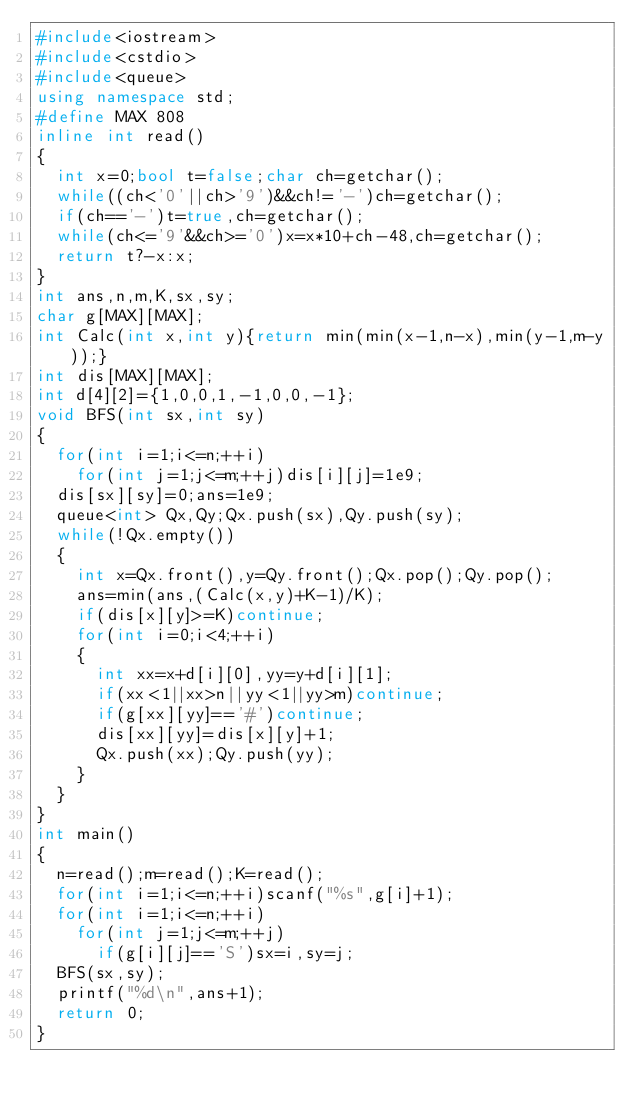<code> <loc_0><loc_0><loc_500><loc_500><_C++_>#include<iostream>
#include<cstdio>
#include<queue>
using namespace std;
#define MAX 808
inline int read()
{
	int x=0;bool t=false;char ch=getchar();
	while((ch<'0'||ch>'9')&&ch!='-')ch=getchar();
	if(ch=='-')t=true,ch=getchar();
	while(ch<='9'&&ch>='0')x=x*10+ch-48,ch=getchar();
	return t?-x:x;
}
int ans,n,m,K,sx,sy;
char g[MAX][MAX];
int Calc(int x,int y){return min(min(x-1,n-x),min(y-1,m-y));}
int dis[MAX][MAX];
int d[4][2]={1,0,0,1,-1,0,0,-1};
void BFS(int sx,int sy)
{
	for(int i=1;i<=n;++i)
		for(int j=1;j<=m;++j)dis[i][j]=1e9;
	dis[sx][sy]=0;ans=1e9;
	queue<int> Qx,Qy;Qx.push(sx),Qy.push(sy);
	while(!Qx.empty())
	{
		int x=Qx.front(),y=Qy.front();Qx.pop();Qy.pop();
		ans=min(ans,(Calc(x,y)+K-1)/K);
		if(dis[x][y]>=K)continue;
		for(int i=0;i<4;++i)
		{
			int xx=x+d[i][0],yy=y+d[i][1];
			if(xx<1||xx>n||yy<1||yy>m)continue;
			if(g[xx][yy]=='#')continue;
			dis[xx][yy]=dis[x][y]+1;
			Qx.push(xx);Qy.push(yy);
		}
	}
}
int main()
{
	n=read();m=read();K=read();
	for(int i=1;i<=n;++i)scanf("%s",g[i]+1);
	for(int i=1;i<=n;++i)
		for(int j=1;j<=m;++j)
			if(g[i][j]=='S')sx=i,sy=j;
	BFS(sx,sy);
	printf("%d\n",ans+1);
	return 0;
}
</code> 